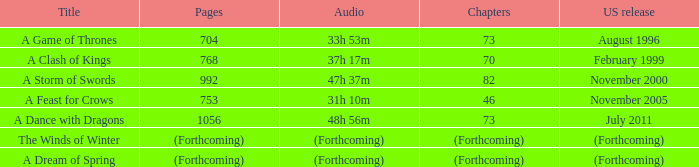Which audio has a Title of a storm of swords? 47h 37m. 